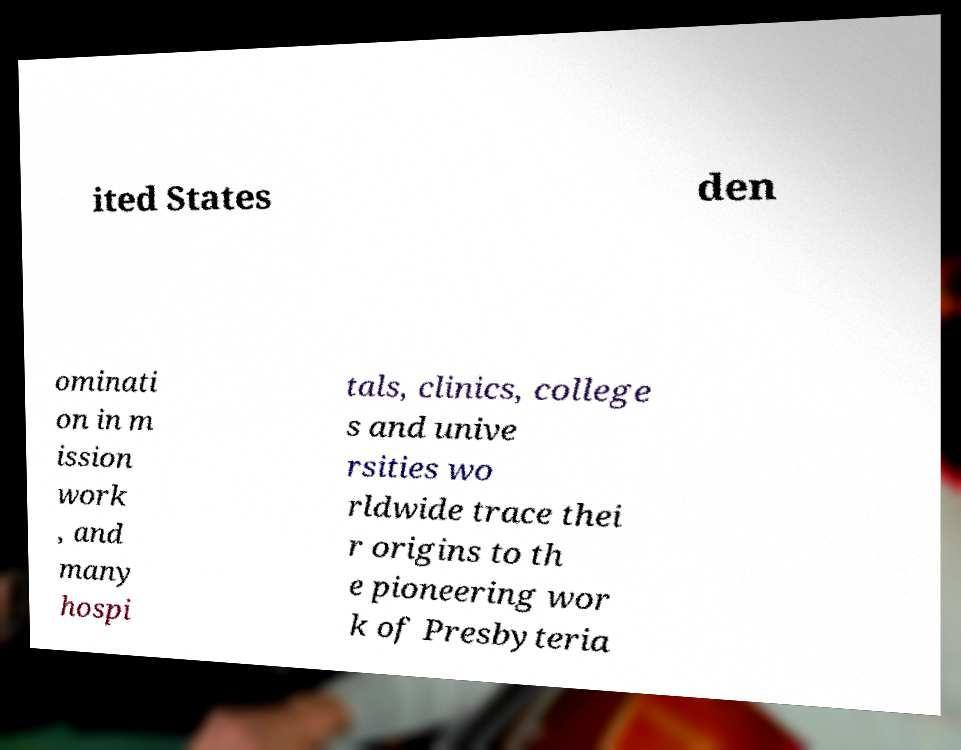Can you accurately transcribe the text from the provided image for me? ited States den ominati on in m ission work , and many hospi tals, clinics, college s and unive rsities wo rldwide trace thei r origins to th e pioneering wor k of Presbyteria 